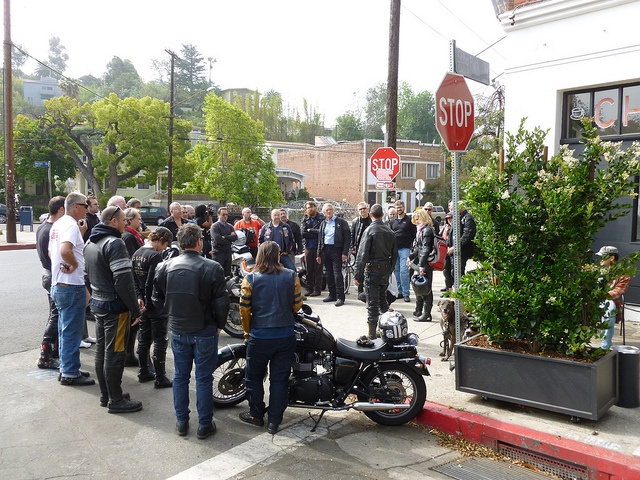Describe the objects in this image and their specific colors. I can see potted plant in white, black, gray, and darkgreen tones, people in white, black, gray, darkgray, and lightgray tones, motorcycle in white, black, gray, darkgray, and lightgray tones, people in white, black, navy, gray, and darkblue tones, and people in white, black, navy, gray, and maroon tones in this image. 